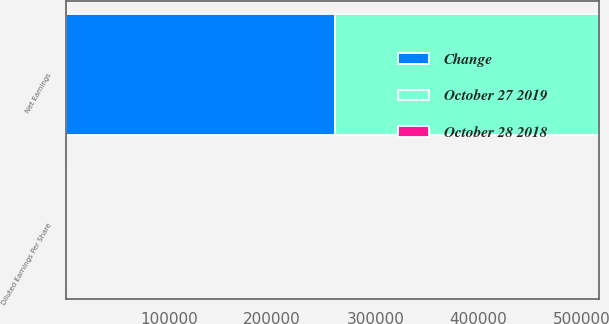Convert chart to OTSL. <chart><loc_0><loc_0><loc_500><loc_500><stacked_bar_chart><ecel><fcel>Net Earnings<fcel>Diluted Earnings Per Share<nl><fcel>October 27 2019<fcel>255503<fcel>0.47<nl><fcel>Change<fcel>261406<fcel>0.48<nl><fcel>October 28 2018<fcel>2.3<fcel>2.1<nl></chart> 